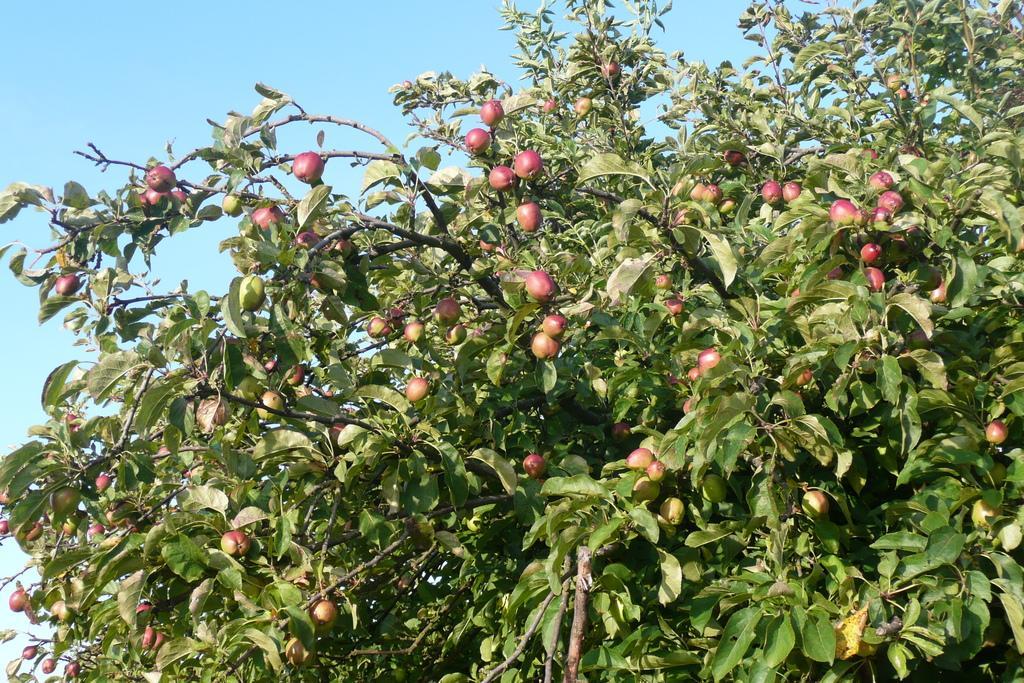Describe this image in one or two sentences. In this image there is a tree to which there are so many fruits. At the top there is the sky. 